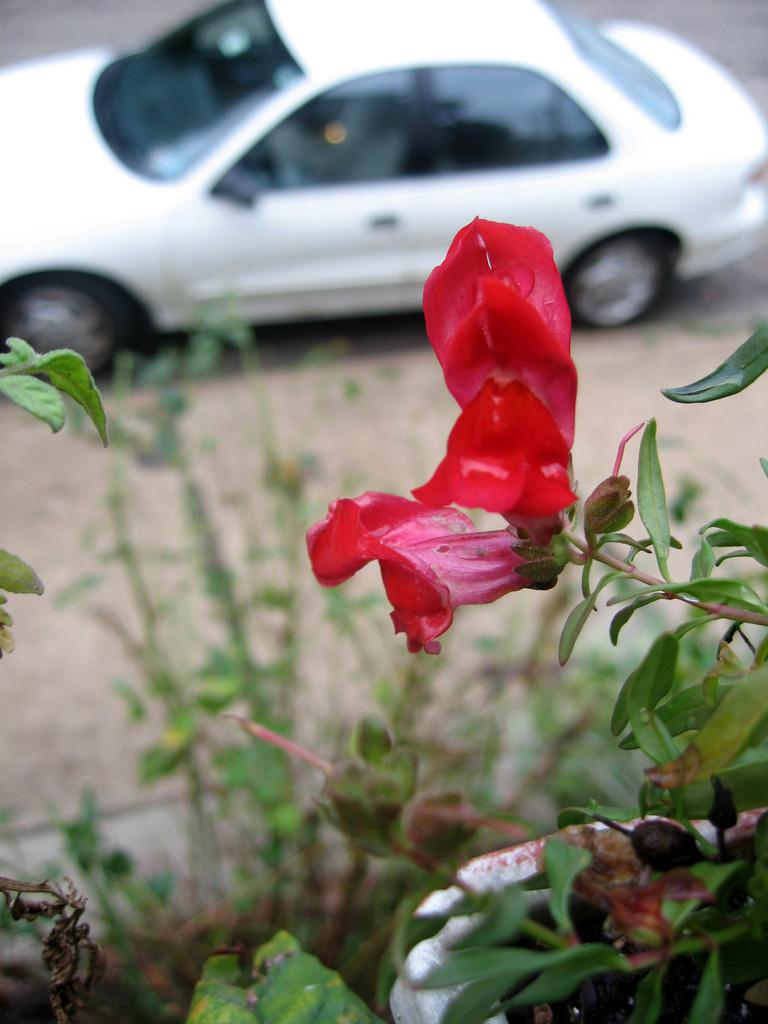What type of living organisms can be seen in the image? Plants and a flower are visible in the image. What is the main object in the image? There is a car in the image. Can you describe the position of the car in the image? The car is placed on a surface. What type of drain can be seen in the image? There is no drain present in the image. Is there a collar visible on the flower in the image? There is no collar present on the flower in the image. 